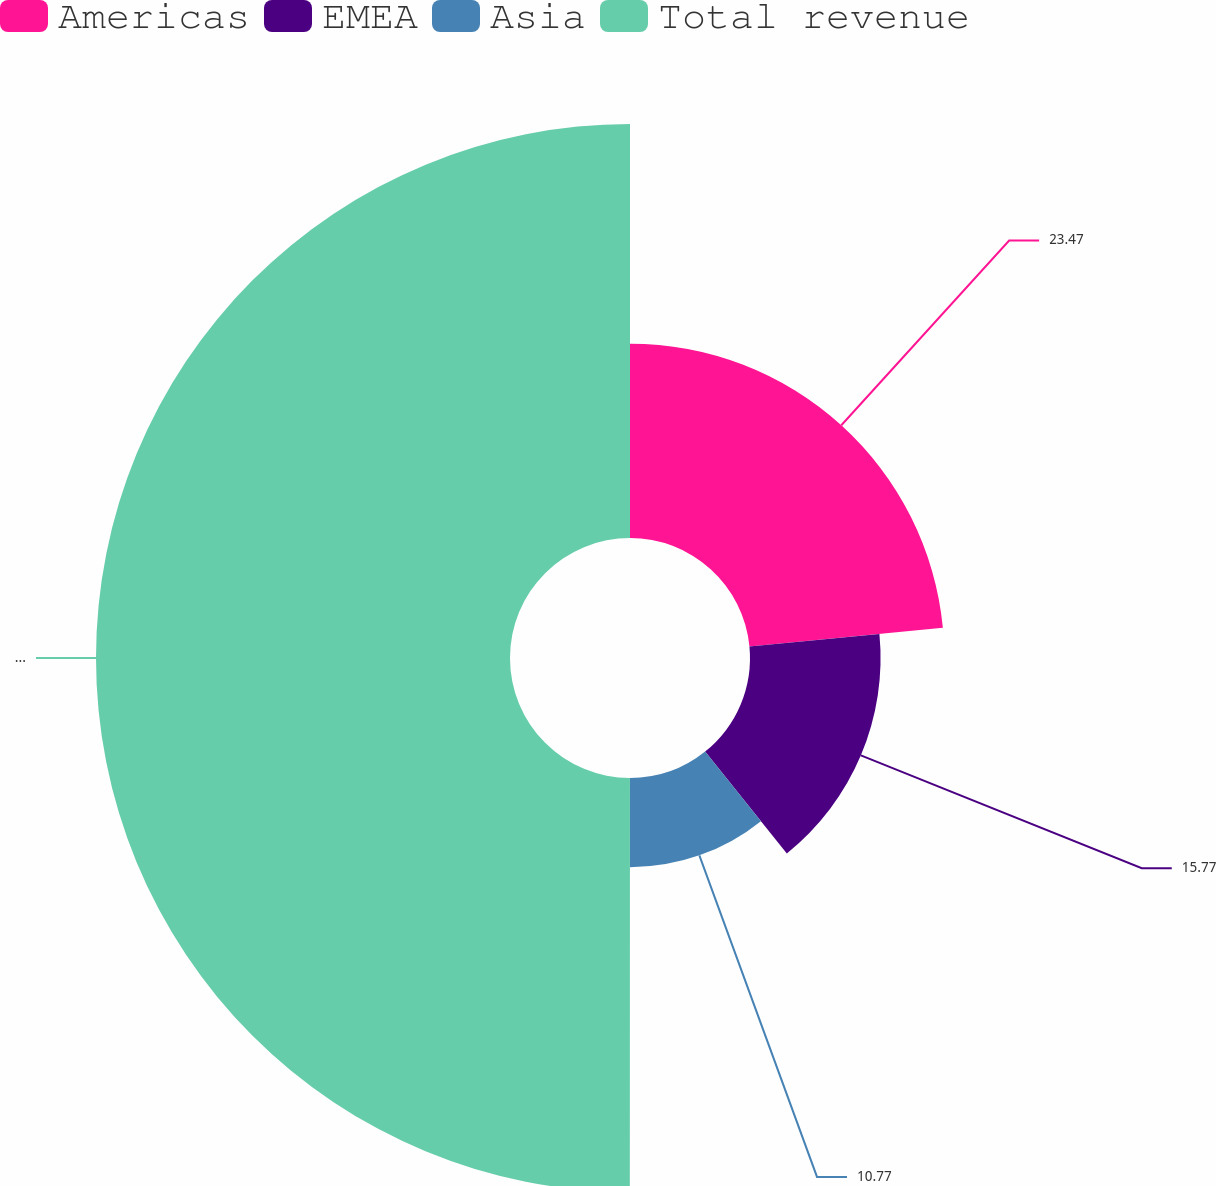Convert chart. <chart><loc_0><loc_0><loc_500><loc_500><pie_chart><fcel>Americas<fcel>EMEA<fcel>Asia<fcel>Total revenue<nl><fcel>23.47%<fcel>15.77%<fcel>10.77%<fcel>50.0%<nl></chart> 